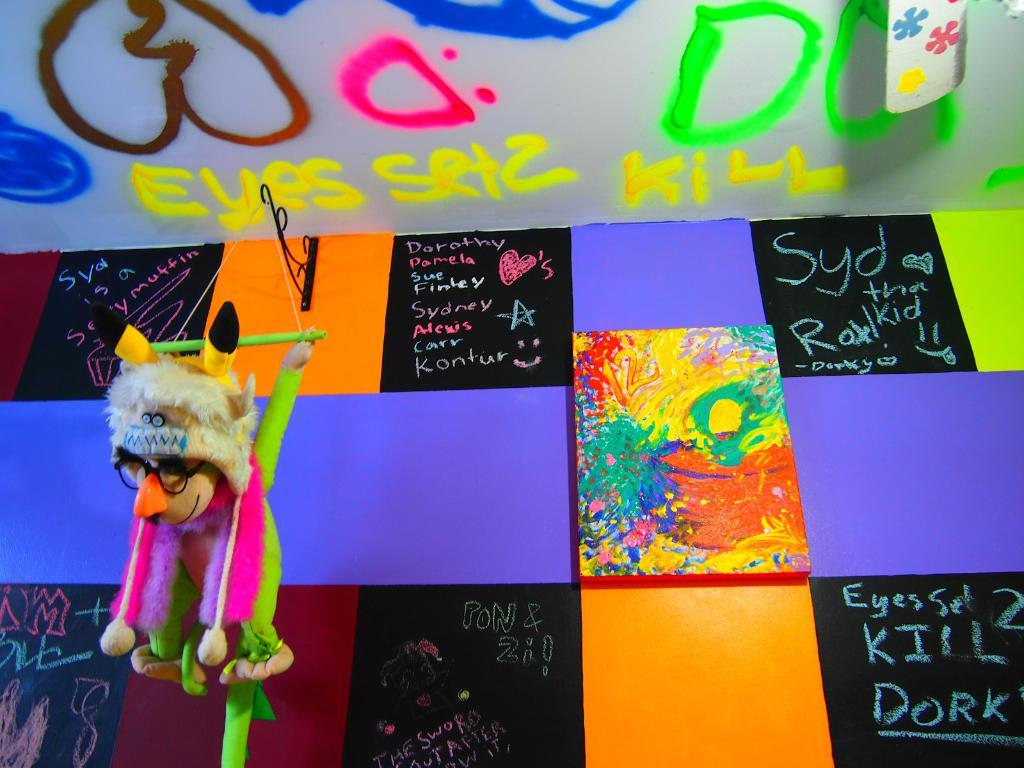<image>
Write a terse but informative summary of the picture. words like EYES are written in colorful markers in a room 